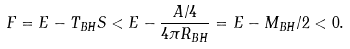Convert formula to latex. <formula><loc_0><loc_0><loc_500><loc_500>F = E - T _ { B H } S < E - \frac { A / 4 } { 4 \pi R _ { B H } } = E - M _ { B H } / 2 < 0 .</formula> 